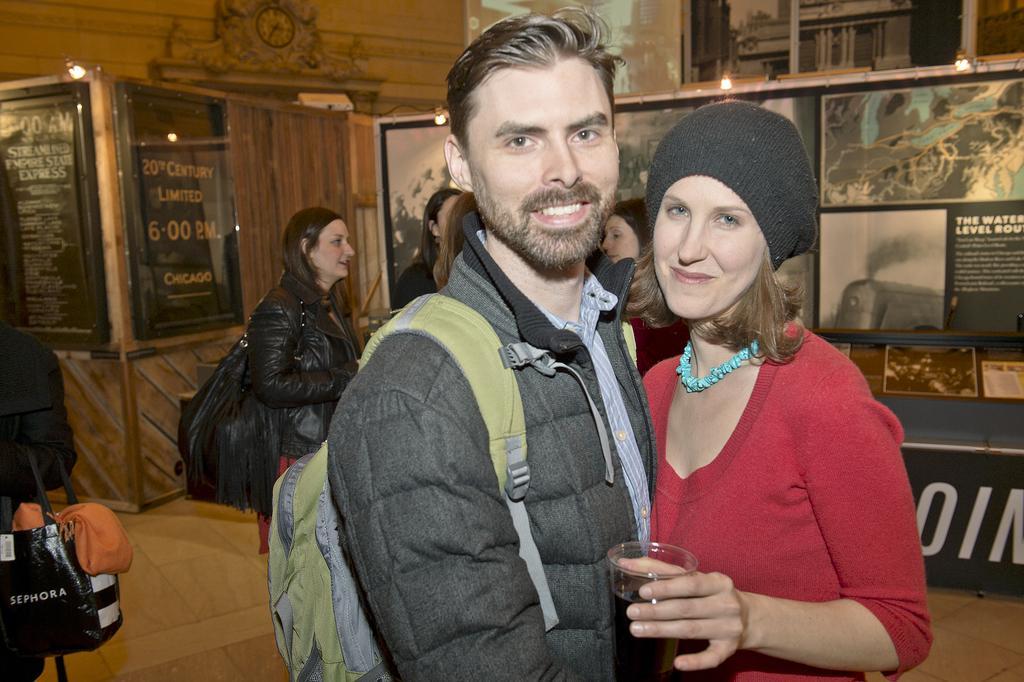Describe this image in one or two sentences. This picture describe about the boy wearing a black color jacket with a green backpack on the back and giving a pose into the camera. Beside we can see a women wearing red color t- shirt smiling and holding a wine glass in the hand. Behind we can see the poster, wooden door and a clock on the top. Beside two black photo frames. 